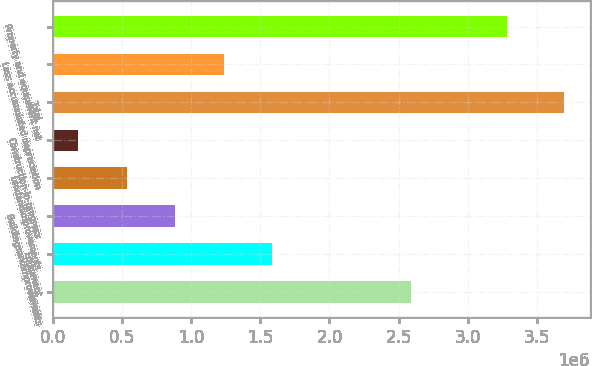Convert chart to OTSL. <chart><loc_0><loc_0><loc_500><loc_500><bar_chart><fcel>Towers<fcel>Equipment<fcel>Buildingsandimprovements<fcel>Landandimprovements<fcel>Construction-in-progress<fcel>Total<fcel>Less accumulated depreciation<fcel>Property and equipment net<nl><fcel>2.58862e+06<fcel>1.58723e+06<fcel>883637<fcel>531840<fcel>180042<fcel>3.69802e+06<fcel>1.23544e+06<fcel>3.28757e+06<nl></chart> 